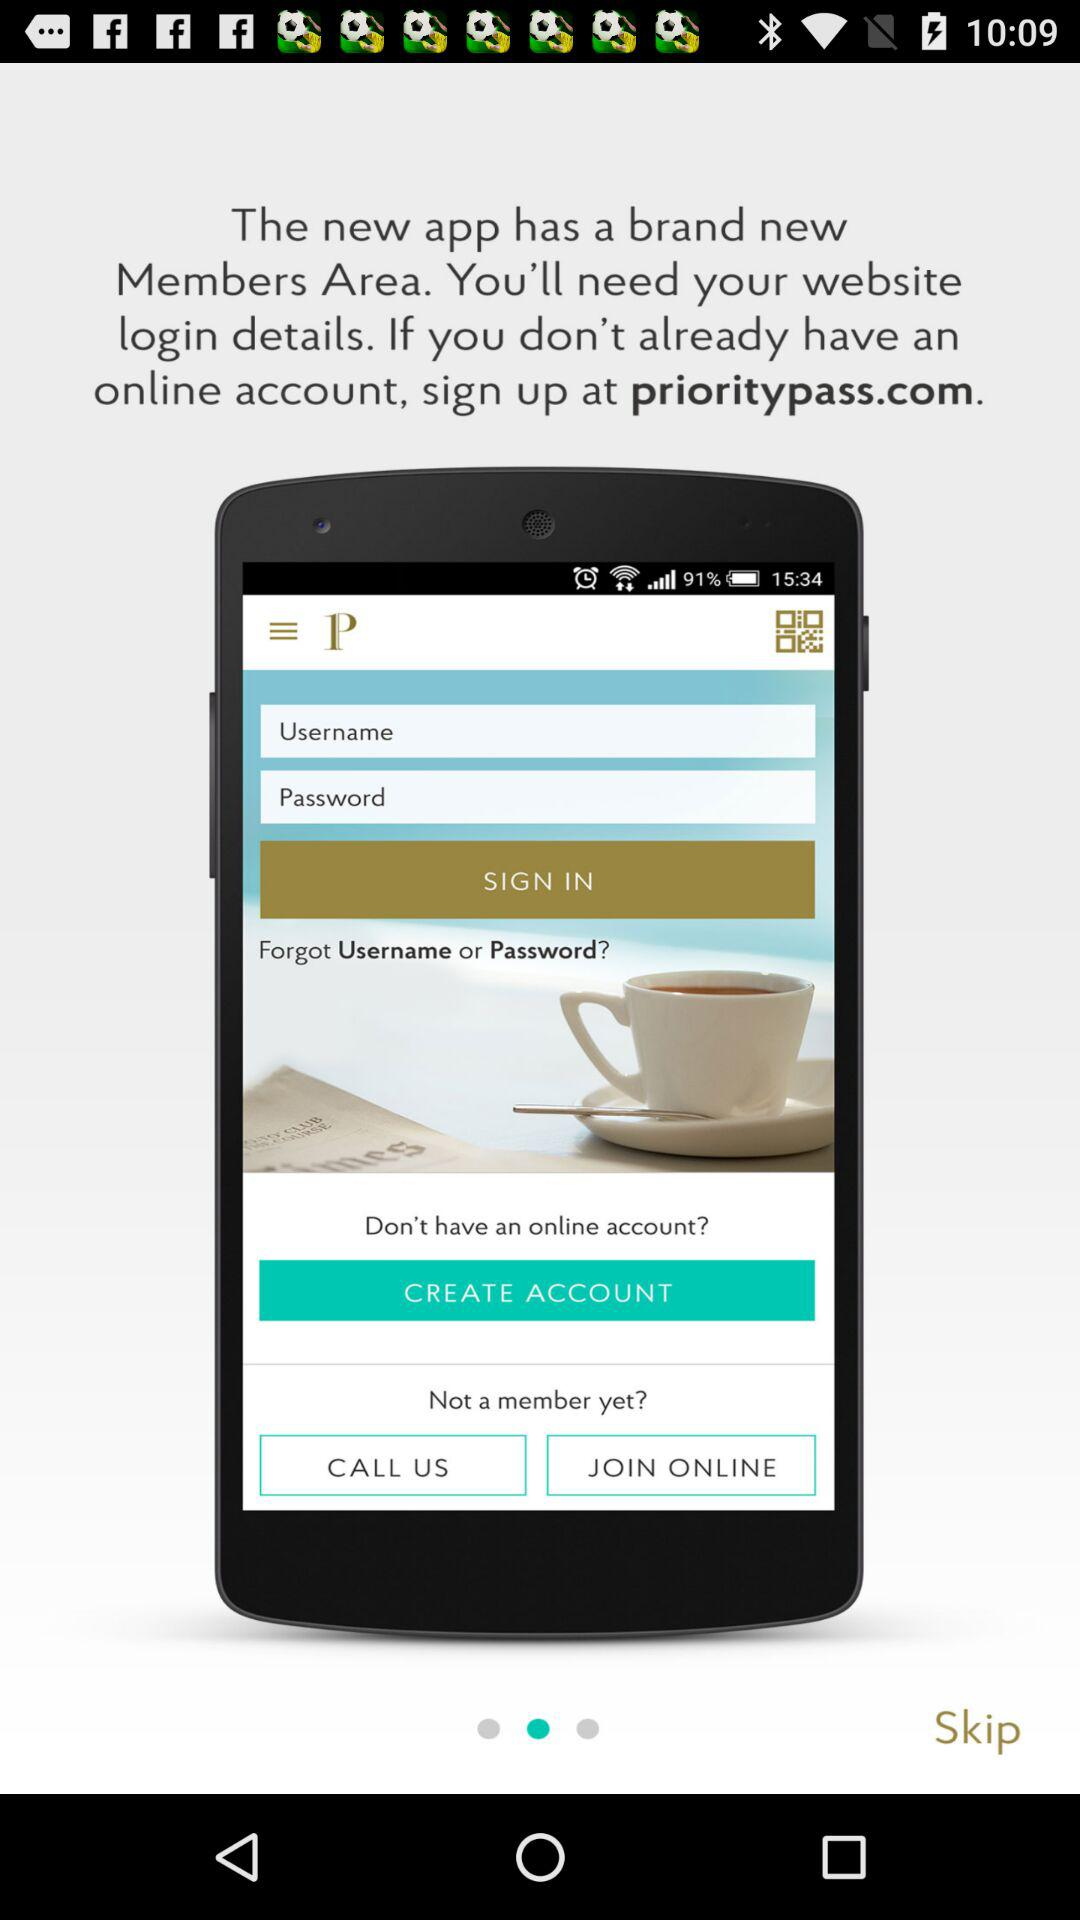What is the application name? The application name is "prioritypass". 